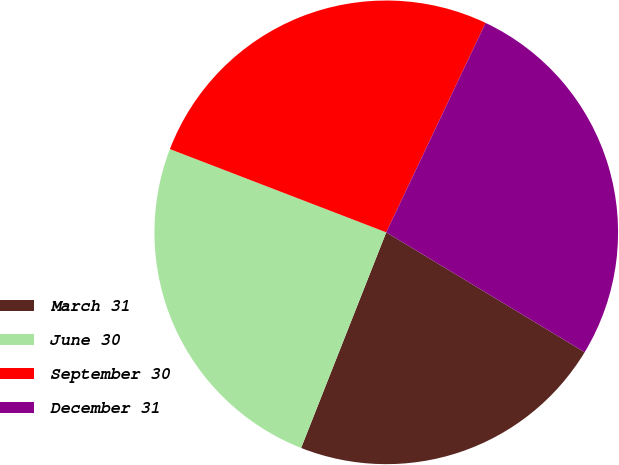Convert chart. <chart><loc_0><loc_0><loc_500><loc_500><pie_chart><fcel>March 31<fcel>June 30<fcel>September 30<fcel>December 31<nl><fcel>22.33%<fcel>24.86%<fcel>26.2%<fcel>26.6%<nl></chart> 